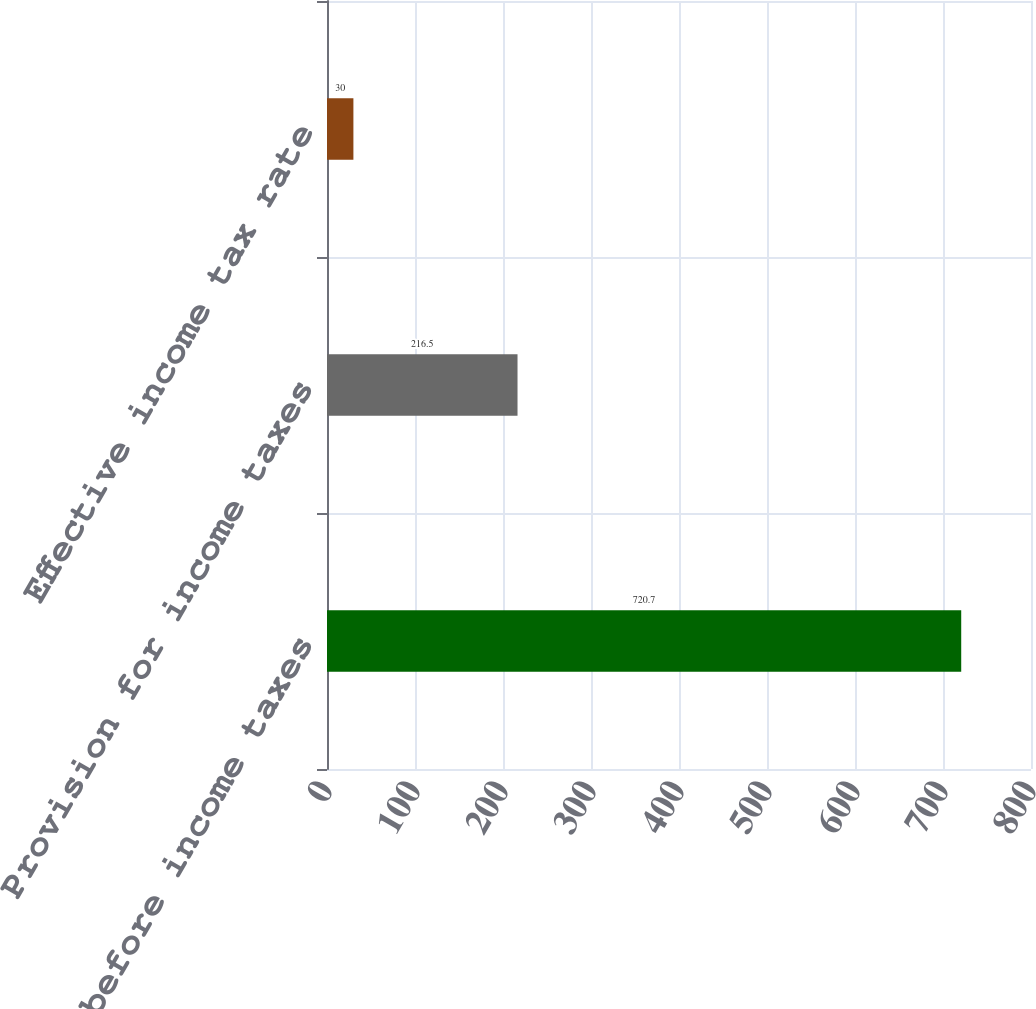Convert chart to OTSL. <chart><loc_0><loc_0><loc_500><loc_500><bar_chart><fcel>Income before income taxes<fcel>Provision for income taxes<fcel>Effective income tax rate<nl><fcel>720.7<fcel>216.5<fcel>30<nl></chart> 